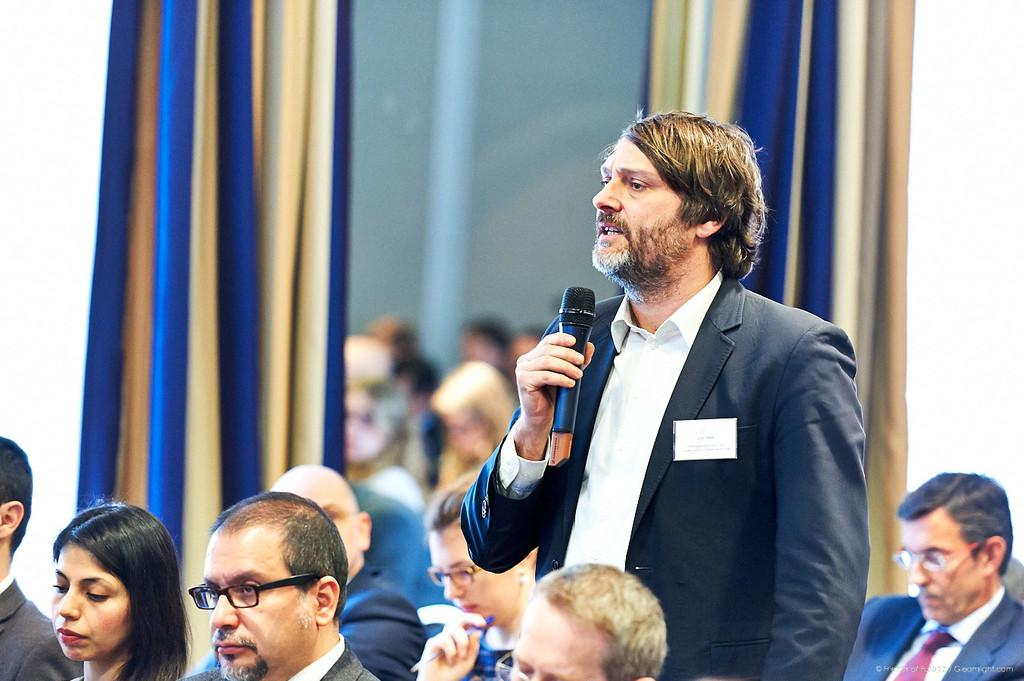What is the man in the image doing? The man is talking on a microphone in the image. What is the man wearing? The man is wearing a black suit in the image. Are there other people in the image besides the man? Yes, there are other people in the image. What can be seen in the background of the image? There is a curtain and a wall in the image. How many lizards are crawling on the wall in the image? There are no lizards present in the image; it only features a man talking on a microphone, a black suit, other people, a curtain, and a wall. 